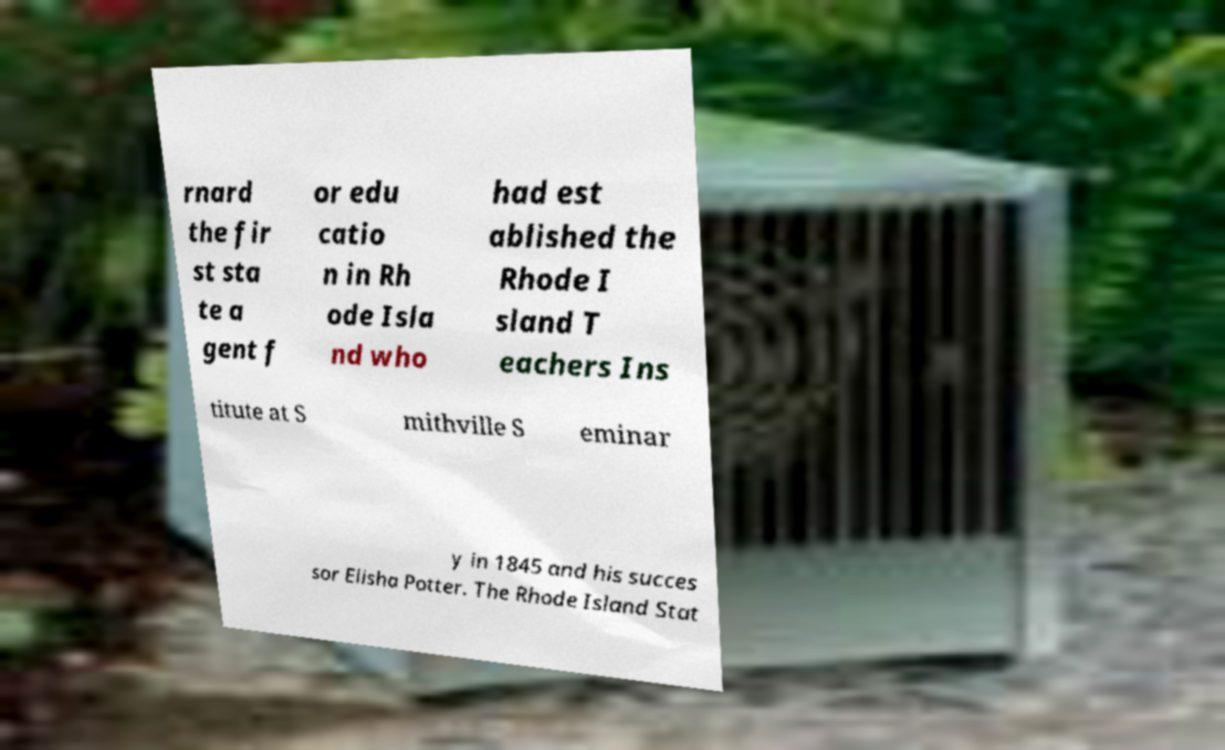For documentation purposes, I need the text within this image transcribed. Could you provide that? rnard the fir st sta te a gent f or edu catio n in Rh ode Isla nd who had est ablished the Rhode I sland T eachers Ins titute at S mithville S eminar y in 1845 and his succes sor Elisha Potter. The Rhode Island Stat 